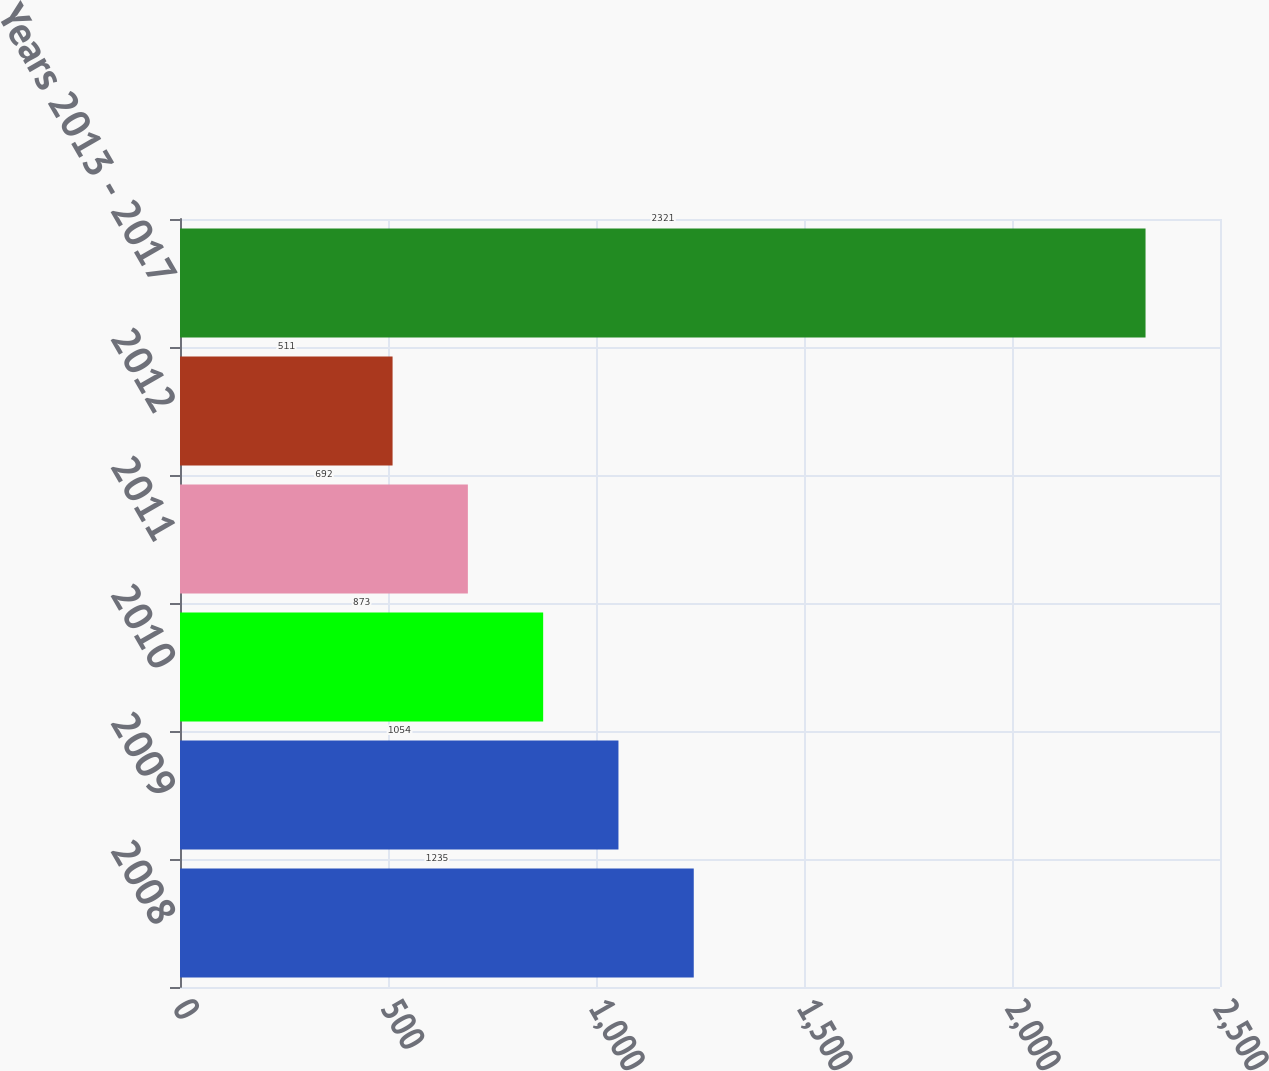Convert chart. <chart><loc_0><loc_0><loc_500><loc_500><bar_chart><fcel>2008<fcel>2009<fcel>2010<fcel>2011<fcel>2012<fcel>Years 2013 - 2017<nl><fcel>1235<fcel>1054<fcel>873<fcel>692<fcel>511<fcel>2321<nl></chart> 